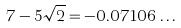<formula> <loc_0><loc_0><loc_500><loc_500>7 - 5 \sqrt { 2 } = - 0 . 0 7 1 0 6 \dots</formula> 